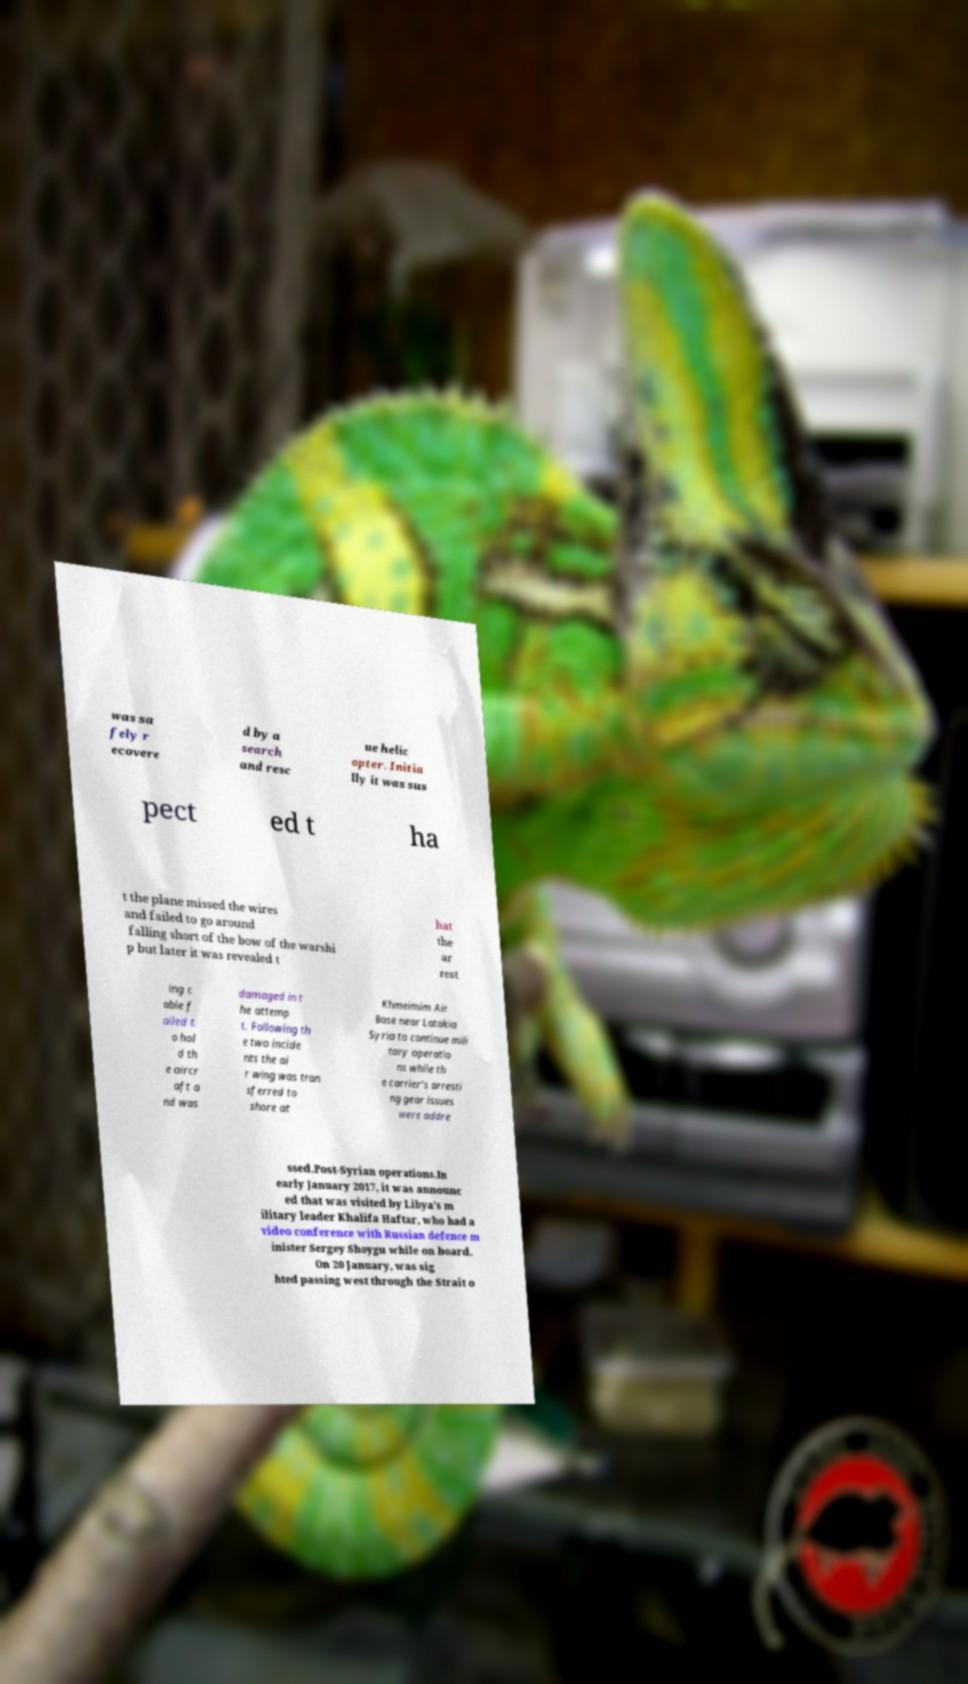Can you read and provide the text displayed in the image?This photo seems to have some interesting text. Can you extract and type it out for me? was sa fely r ecovere d by a search and resc ue helic opter. Initia lly it was sus pect ed t ha t the plane missed the wires and failed to go around falling short of the bow of the warshi p but later it was revealed t hat the ar rest ing c able f ailed t o hol d th e aircr aft a nd was damaged in t he attemp t. Following th e two incide nts the ai r wing was tran sferred to shore at Khmeimim Air Base near Latakia Syria to continue mili tary operatio ns while th e carrier's arresti ng gear issues were addre ssed.Post-Syrian operations.In early January 2017, it was announc ed that was visited by Libya′s m ilitary leader Khalifa Haftar, who had a video conference with Russian defence m inister Sergey Shoygu while on board. On 20 January, was sig hted passing west through the Strait o 